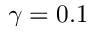<formula> <loc_0><loc_0><loc_500><loc_500>\gamma = 0 . 1</formula> 